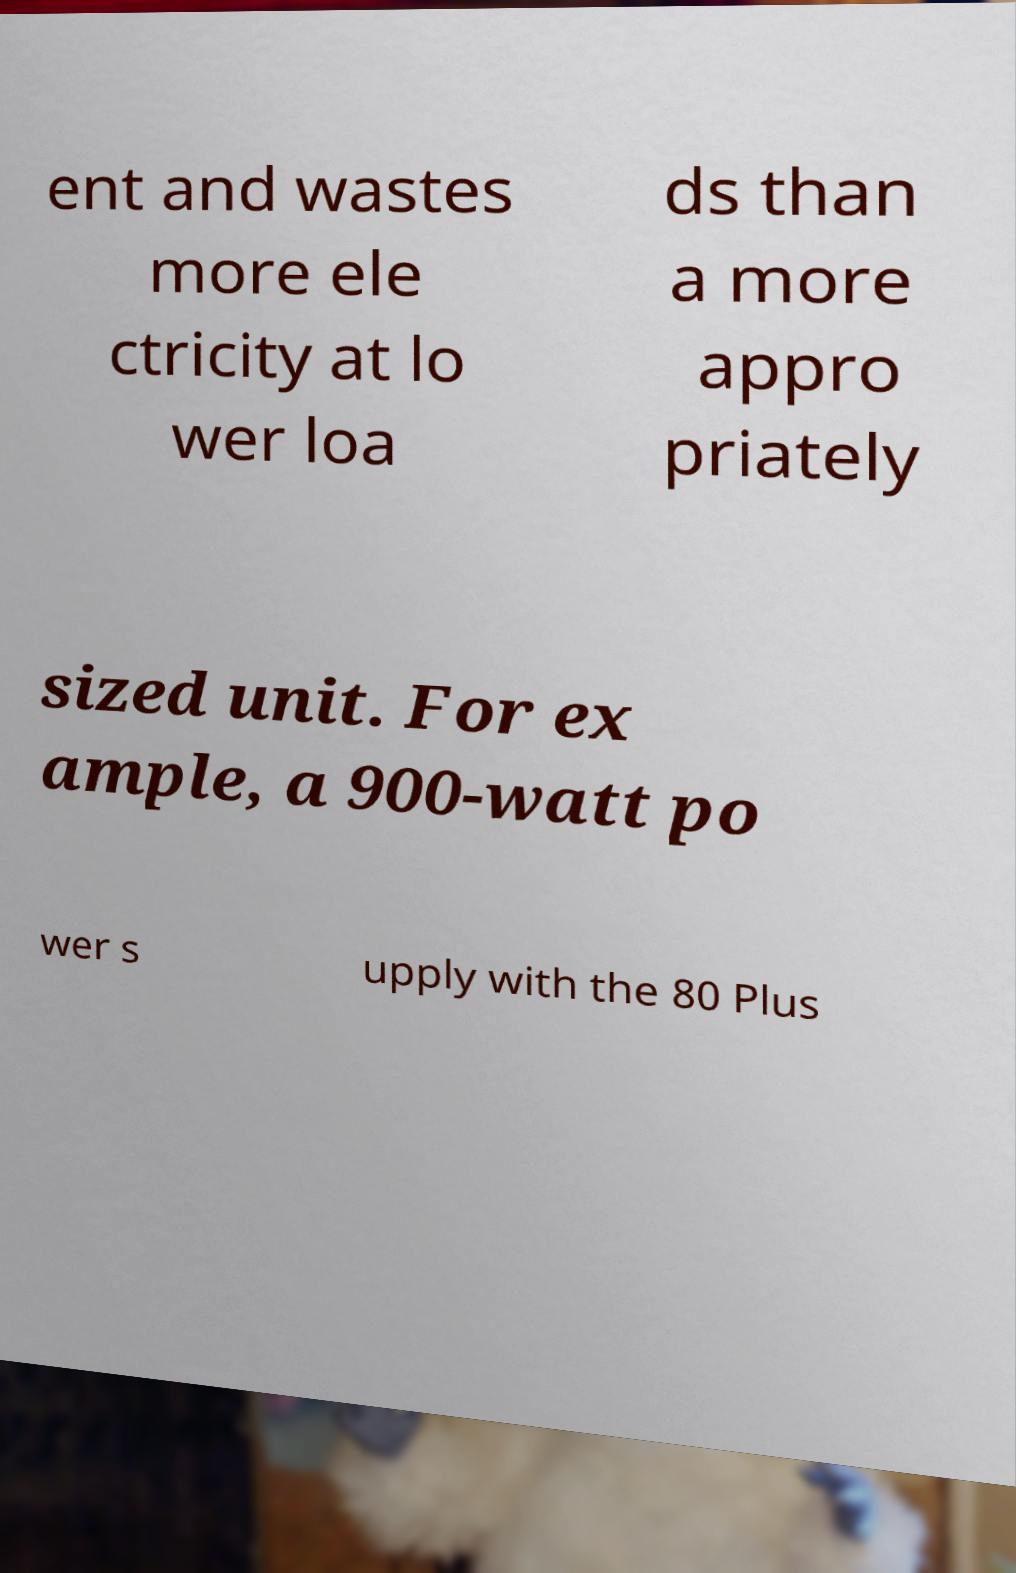For documentation purposes, I need the text within this image transcribed. Could you provide that? ent and wastes more ele ctricity at lo wer loa ds than a more appro priately sized unit. For ex ample, a 900-watt po wer s upply with the 80 Plus 